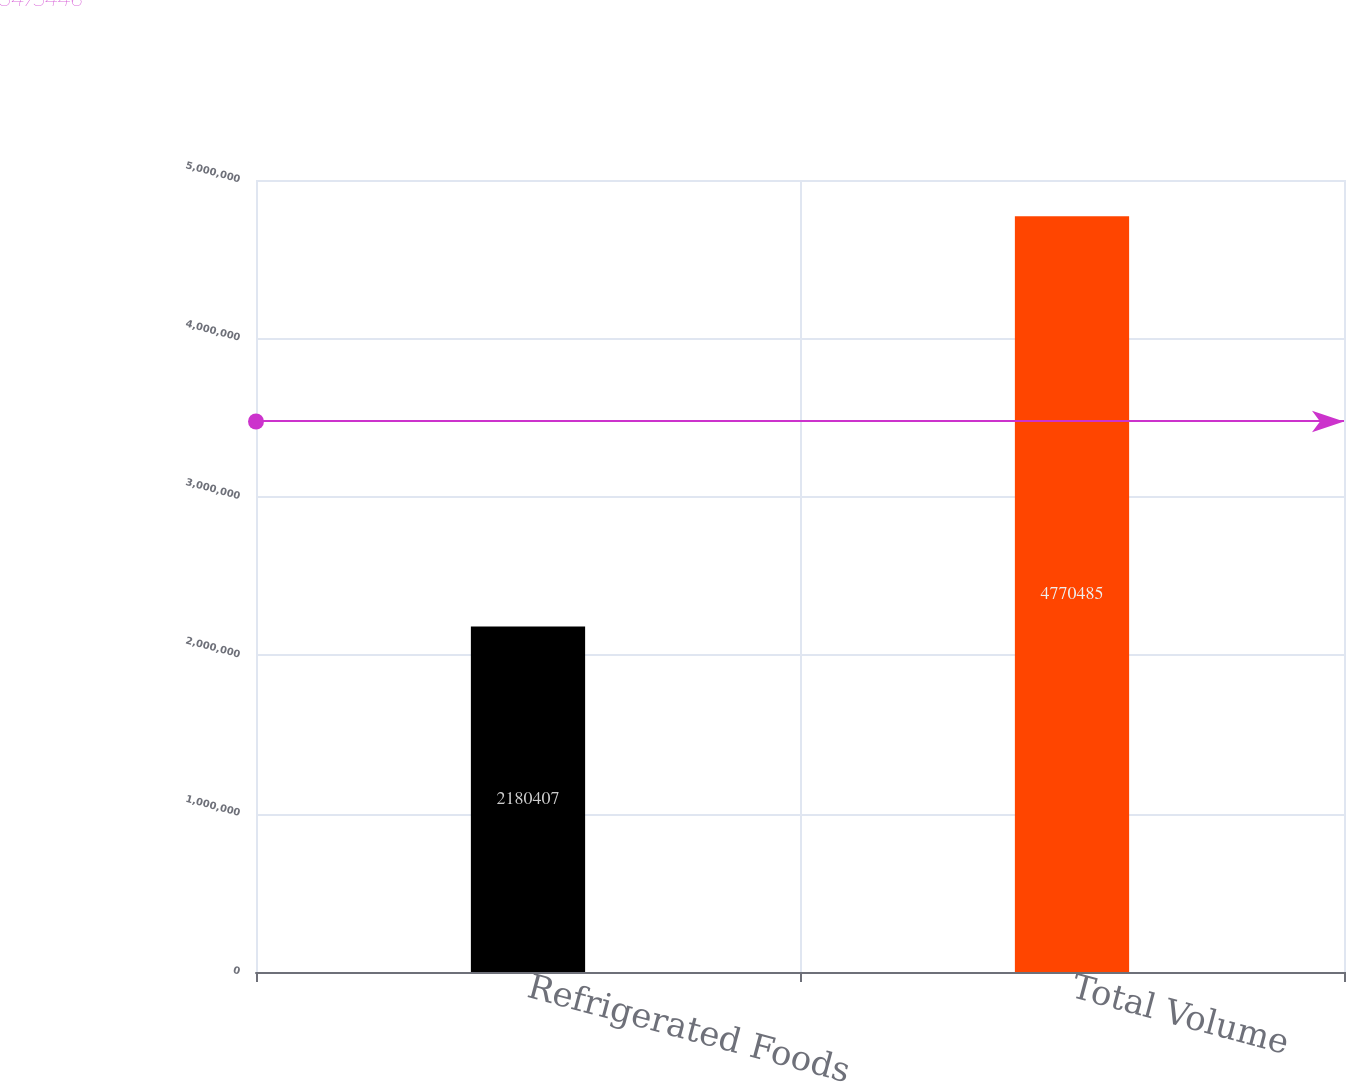Convert chart to OTSL. <chart><loc_0><loc_0><loc_500><loc_500><bar_chart><fcel>Refrigerated Foods<fcel>Total Volume<nl><fcel>2.18041e+06<fcel>4.77048e+06<nl></chart> 